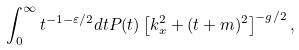Convert formula to latex. <formula><loc_0><loc_0><loc_500><loc_500>\int _ { 0 } ^ { \infty } t ^ { - 1 - \varepsilon / 2 } d t P ( t ) \left [ k _ { x } ^ { 2 } + ( t + m ) ^ { 2 } \right ] ^ { - g / 2 } ,</formula> 